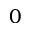Convert formula to latex. <formula><loc_0><loc_0><loc_500><loc_500>0</formula> 